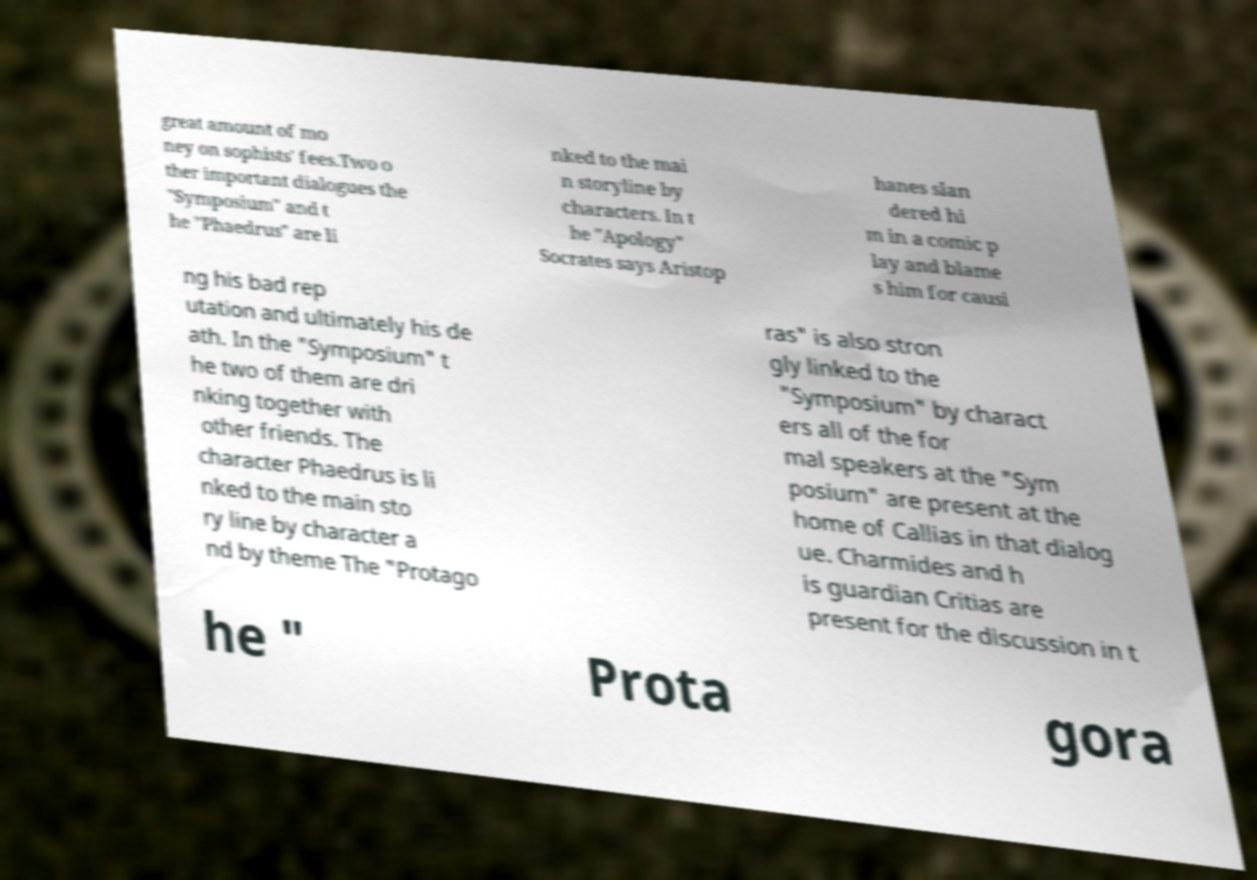What messages or text are displayed in this image? I need them in a readable, typed format. great amount of mo ney on sophists' fees.Two o ther important dialogues the "Symposium" and t he "Phaedrus" are li nked to the mai n storyline by characters. In t he "Apology" Socrates says Aristop hanes slan dered hi m in a comic p lay and blame s him for causi ng his bad rep utation and ultimately his de ath. In the "Symposium" t he two of them are dri nking together with other friends. The character Phaedrus is li nked to the main sto ry line by character a nd by theme The "Protago ras" is also stron gly linked to the "Symposium" by charact ers all of the for mal speakers at the "Sym posium" are present at the home of Callias in that dialog ue. Charmides and h is guardian Critias are present for the discussion in t he " Prota gora 